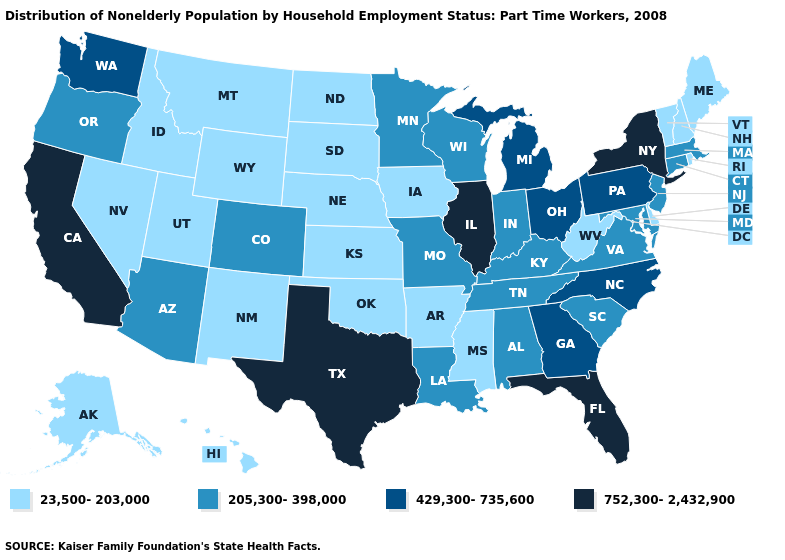How many symbols are there in the legend?
Concise answer only. 4. What is the highest value in the South ?
Write a very short answer. 752,300-2,432,900. What is the highest value in states that border Vermont?
Quick response, please. 752,300-2,432,900. Does Hawaii have a lower value than Kentucky?
Write a very short answer. Yes. Does Texas have the highest value in the South?
Give a very brief answer. Yes. Name the states that have a value in the range 205,300-398,000?
Quick response, please. Alabama, Arizona, Colorado, Connecticut, Indiana, Kentucky, Louisiana, Maryland, Massachusetts, Minnesota, Missouri, New Jersey, Oregon, South Carolina, Tennessee, Virginia, Wisconsin. What is the value of Minnesota?
Answer briefly. 205,300-398,000. Name the states that have a value in the range 752,300-2,432,900?
Keep it brief. California, Florida, Illinois, New York, Texas. What is the lowest value in the USA?
Write a very short answer. 23,500-203,000. What is the highest value in the USA?
Short answer required. 752,300-2,432,900. Name the states that have a value in the range 429,300-735,600?
Short answer required. Georgia, Michigan, North Carolina, Ohio, Pennsylvania, Washington. What is the value of Georgia?
Concise answer only. 429,300-735,600. What is the value of Colorado?
Short answer required. 205,300-398,000. What is the lowest value in the MidWest?
Concise answer only. 23,500-203,000. Name the states that have a value in the range 23,500-203,000?
Short answer required. Alaska, Arkansas, Delaware, Hawaii, Idaho, Iowa, Kansas, Maine, Mississippi, Montana, Nebraska, Nevada, New Hampshire, New Mexico, North Dakota, Oklahoma, Rhode Island, South Dakota, Utah, Vermont, West Virginia, Wyoming. 